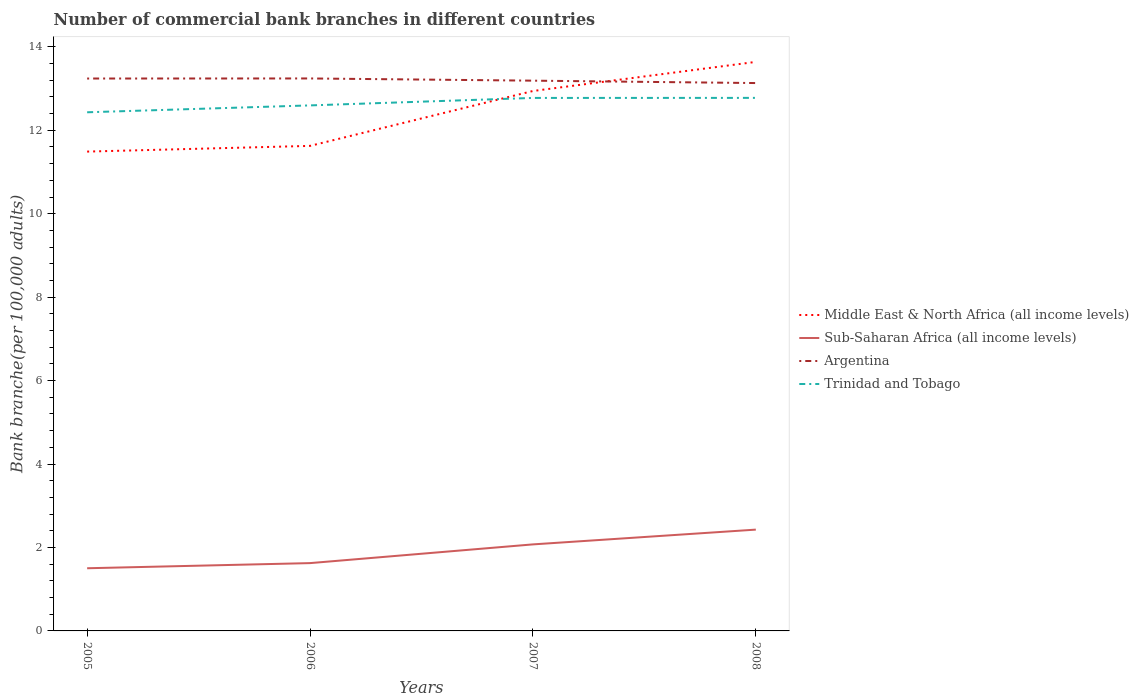Does the line corresponding to Trinidad and Tobago intersect with the line corresponding to Argentina?
Provide a short and direct response. No. Across all years, what is the maximum number of commercial bank branches in Trinidad and Tobago?
Your answer should be compact. 12.43. What is the total number of commercial bank branches in Argentina in the graph?
Give a very brief answer. 0.06. What is the difference between the highest and the second highest number of commercial bank branches in Middle East & North Africa (all income levels)?
Your answer should be compact. 2.15. How many lines are there?
Your response must be concise. 4. How many years are there in the graph?
Keep it short and to the point. 4. Are the values on the major ticks of Y-axis written in scientific E-notation?
Offer a very short reply. No. How are the legend labels stacked?
Your answer should be very brief. Vertical. What is the title of the graph?
Your answer should be compact. Number of commercial bank branches in different countries. What is the label or title of the X-axis?
Give a very brief answer. Years. What is the label or title of the Y-axis?
Make the answer very short. Bank branche(per 100,0 adults). What is the Bank branche(per 100,000 adults) in Middle East & North Africa (all income levels) in 2005?
Ensure brevity in your answer.  11.49. What is the Bank branche(per 100,000 adults) of Sub-Saharan Africa (all income levels) in 2005?
Your response must be concise. 1.5. What is the Bank branche(per 100,000 adults) of Argentina in 2005?
Give a very brief answer. 13.24. What is the Bank branche(per 100,000 adults) of Trinidad and Tobago in 2005?
Make the answer very short. 12.43. What is the Bank branche(per 100,000 adults) of Middle East & North Africa (all income levels) in 2006?
Your answer should be very brief. 11.63. What is the Bank branche(per 100,000 adults) of Sub-Saharan Africa (all income levels) in 2006?
Ensure brevity in your answer.  1.63. What is the Bank branche(per 100,000 adults) in Argentina in 2006?
Provide a short and direct response. 13.24. What is the Bank branche(per 100,000 adults) in Trinidad and Tobago in 2006?
Provide a short and direct response. 12.6. What is the Bank branche(per 100,000 adults) of Middle East & North Africa (all income levels) in 2007?
Your response must be concise. 12.94. What is the Bank branche(per 100,000 adults) in Sub-Saharan Africa (all income levels) in 2007?
Keep it short and to the point. 2.07. What is the Bank branche(per 100,000 adults) in Argentina in 2007?
Provide a short and direct response. 13.19. What is the Bank branche(per 100,000 adults) of Trinidad and Tobago in 2007?
Your answer should be compact. 12.77. What is the Bank branche(per 100,000 adults) in Middle East & North Africa (all income levels) in 2008?
Provide a succinct answer. 13.64. What is the Bank branche(per 100,000 adults) of Sub-Saharan Africa (all income levels) in 2008?
Ensure brevity in your answer.  2.43. What is the Bank branche(per 100,000 adults) of Argentina in 2008?
Give a very brief answer. 13.13. What is the Bank branche(per 100,000 adults) in Trinidad and Tobago in 2008?
Make the answer very short. 12.78. Across all years, what is the maximum Bank branche(per 100,000 adults) in Middle East & North Africa (all income levels)?
Provide a succinct answer. 13.64. Across all years, what is the maximum Bank branche(per 100,000 adults) of Sub-Saharan Africa (all income levels)?
Offer a terse response. 2.43. Across all years, what is the maximum Bank branche(per 100,000 adults) of Argentina?
Your answer should be very brief. 13.24. Across all years, what is the maximum Bank branche(per 100,000 adults) of Trinidad and Tobago?
Offer a terse response. 12.78. Across all years, what is the minimum Bank branche(per 100,000 adults) in Middle East & North Africa (all income levels)?
Provide a short and direct response. 11.49. Across all years, what is the minimum Bank branche(per 100,000 adults) of Sub-Saharan Africa (all income levels)?
Your response must be concise. 1.5. Across all years, what is the minimum Bank branche(per 100,000 adults) of Argentina?
Offer a very short reply. 13.13. Across all years, what is the minimum Bank branche(per 100,000 adults) of Trinidad and Tobago?
Offer a very short reply. 12.43. What is the total Bank branche(per 100,000 adults) in Middle East & North Africa (all income levels) in the graph?
Give a very brief answer. 49.69. What is the total Bank branche(per 100,000 adults) in Sub-Saharan Africa (all income levels) in the graph?
Provide a short and direct response. 7.63. What is the total Bank branche(per 100,000 adults) in Argentina in the graph?
Provide a succinct answer. 52.8. What is the total Bank branche(per 100,000 adults) of Trinidad and Tobago in the graph?
Provide a succinct answer. 50.58. What is the difference between the Bank branche(per 100,000 adults) in Middle East & North Africa (all income levels) in 2005 and that in 2006?
Your answer should be compact. -0.14. What is the difference between the Bank branche(per 100,000 adults) in Sub-Saharan Africa (all income levels) in 2005 and that in 2006?
Your answer should be very brief. -0.12. What is the difference between the Bank branche(per 100,000 adults) of Argentina in 2005 and that in 2006?
Provide a short and direct response. -0. What is the difference between the Bank branche(per 100,000 adults) in Trinidad and Tobago in 2005 and that in 2006?
Offer a very short reply. -0.16. What is the difference between the Bank branche(per 100,000 adults) of Middle East & North Africa (all income levels) in 2005 and that in 2007?
Your response must be concise. -1.45. What is the difference between the Bank branche(per 100,000 adults) of Sub-Saharan Africa (all income levels) in 2005 and that in 2007?
Give a very brief answer. -0.57. What is the difference between the Bank branche(per 100,000 adults) of Argentina in 2005 and that in 2007?
Your answer should be compact. 0.05. What is the difference between the Bank branche(per 100,000 adults) in Trinidad and Tobago in 2005 and that in 2007?
Your response must be concise. -0.34. What is the difference between the Bank branche(per 100,000 adults) in Middle East & North Africa (all income levels) in 2005 and that in 2008?
Your answer should be compact. -2.15. What is the difference between the Bank branche(per 100,000 adults) in Sub-Saharan Africa (all income levels) in 2005 and that in 2008?
Ensure brevity in your answer.  -0.93. What is the difference between the Bank branche(per 100,000 adults) of Argentina in 2005 and that in 2008?
Give a very brief answer. 0.11. What is the difference between the Bank branche(per 100,000 adults) in Trinidad and Tobago in 2005 and that in 2008?
Provide a succinct answer. -0.35. What is the difference between the Bank branche(per 100,000 adults) in Middle East & North Africa (all income levels) in 2006 and that in 2007?
Make the answer very short. -1.32. What is the difference between the Bank branche(per 100,000 adults) in Sub-Saharan Africa (all income levels) in 2006 and that in 2007?
Your response must be concise. -0.45. What is the difference between the Bank branche(per 100,000 adults) in Argentina in 2006 and that in 2007?
Give a very brief answer. 0.05. What is the difference between the Bank branche(per 100,000 adults) of Trinidad and Tobago in 2006 and that in 2007?
Your answer should be very brief. -0.18. What is the difference between the Bank branche(per 100,000 adults) in Middle East & North Africa (all income levels) in 2006 and that in 2008?
Make the answer very short. -2.01. What is the difference between the Bank branche(per 100,000 adults) of Sub-Saharan Africa (all income levels) in 2006 and that in 2008?
Your answer should be very brief. -0.8. What is the difference between the Bank branche(per 100,000 adults) of Argentina in 2006 and that in 2008?
Ensure brevity in your answer.  0.11. What is the difference between the Bank branche(per 100,000 adults) in Trinidad and Tobago in 2006 and that in 2008?
Offer a terse response. -0.18. What is the difference between the Bank branche(per 100,000 adults) in Middle East & North Africa (all income levels) in 2007 and that in 2008?
Make the answer very short. -0.7. What is the difference between the Bank branche(per 100,000 adults) in Sub-Saharan Africa (all income levels) in 2007 and that in 2008?
Make the answer very short. -0.35. What is the difference between the Bank branche(per 100,000 adults) in Argentina in 2007 and that in 2008?
Keep it short and to the point. 0.06. What is the difference between the Bank branche(per 100,000 adults) in Trinidad and Tobago in 2007 and that in 2008?
Provide a succinct answer. -0. What is the difference between the Bank branche(per 100,000 adults) of Middle East & North Africa (all income levels) in 2005 and the Bank branche(per 100,000 adults) of Sub-Saharan Africa (all income levels) in 2006?
Your answer should be compact. 9.86. What is the difference between the Bank branche(per 100,000 adults) of Middle East & North Africa (all income levels) in 2005 and the Bank branche(per 100,000 adults) of Argentina in 2006?
Offer a very short reply. -1.75. What is the difference between the Bank branche(per 100,000 adults) of Middle East & North Africa (all income levels) in 2005 and the Bank branche(per 100,000 adults) of Trinidad and Tobago in 2006?
Make the answer very short. -1.11. What is the difference between the Bank branche(per 100,000 adults) of Sub-Saharan Africa (all income levels) in 2005 and the Bank branche(per 100,000 adults) of Argentina in 2006?
Offer a terse response. -11.74. What is the difference between the Bank branche(per 100,000 adults) of Sub-Saharan Africa (all income levels) in 2005 and the Bank branche(per 100,000 adults) of Trinidad and Tobago in 2006?
Your answer should be compact. -11.09. What is the difference between the Bank branche(per 100,000 adults) of Argentina in 2005 and the Bank branche(per 100,000 adults) of Trinidad and Tobago in 2006?
Keep it short and to the point. 0.64. What is the difference between the Bank branche(per 100,000 adults) of Middle East & North Africa (all income levels) in 2005 and the Bank branche(per 100,000 adults) of Sub-Saharan Africa (all income levels) in 2007?
Offer a terse response. 9.41. What is the difference between the Bank branche(per 100,000 adults) of Middle East & North Africa (all income levels) in 2005 and the Bank branche(per 100,000 adults) of Trinidad and Tobago in 2007?
Your response must be concise. -1.29. What is the difference between the Bank branche(per 100,000 adults) in Sub-Saharan Africa (all income levels) in 2005 and the Bank branche(per 100,000 adults) in Argentina in 2007?
Keep it short and to the point. -11.69. What is the difference between the Bank branche(per 100,000 adults) of Sub-Saharan Africa (all income levels) in 2005 and the Bank branche(per 100,000 adults) of Trinidad and Tobago in 2007?
Your answer should be very brief. -11.27. What is the difference between the Bank branche(per 100,000 adults) of Argentina in 2005 and the Bank branche(per 100,000 adults) of Trinidad and Tobago in 2007?
Give a very brief answer. 0.47. What is the difference between the Bank branche(per 100,000 adults) in Middle East & North Africa (all income levels) in 2005 and the Bank branche(per 100,000 adults) in Sub-Saharan Africa (all income levels) in 2008?
Offer a terse response. 9.06. What is the difference between the Bank branche(per 100,000 adults) of Middle East & North Africa (all income levels) in 2005 and the Bank branche(per 100,000 adults) of Argentina in 2008?
Your answer should be very brief. -1.64. What is the difference between the Bank branche(per 100,000 adults) in Middle East & North Africa (all income levels) in 2005 and the Bank branche(per 100,000 adults) in Trinidad and Tobago in 2008?
Provide a short and direct response. -1.29. What is the difference between the Bank branche(per 100,000 adults) of Sub-Saharan Africa (all income levels) in 2005 and the Bank branche(per 100,000 adults) of Argentina in 2008?
Make the answer very short. -11.63. What is the difference between the Bank branche(per 100,000 adults) in Sub-Saharan Africa (all income levels) in 2005 and the Bank branche(per 100,000 adults) in Trinidad and Tobago in 2008?
Your response must be concise. -11.27. What is the difference between the Bank branche(per 100,000 adults) of Argentina in 2005 and the Bank branche(per 100,000 adults) of Trinidad and Tobago in 2008?
Your answer should be very brief. 0.46. What is the difference between the Bank branche(per 100,000 adults) of Middle East & North Africa (all income levels) in 2006 and the Bank branche(per 100,000 adults) of Sub-Saharan Africa (all income levels) in 2007?
Make the answer very short. 9.55. What is the difference between the Bank branche(per 100,000 adults) in Middle East & North Africa (all income levels) in 2006 and the Bank branche(per 100,000 adults) in Argentina in 2007?
Offer a very short reply. -1.56. What is the difference between the Bank branche(per 100,000 adults) in Middle East & North Africa (all income levels) in 2006 and the Bank branche(per 100,000 adults) in Trinidad and Tobago in 2007?
Provide a succinct answer. -1.15. What is the difference between the Bank branche(per 100,000 adults) in Sub-Saharan Africa (all income levels) in 2006 and the Bank branche(per 100,000 adults) in Argentina in 2007?
Your answer should be compact. -11.56. What is the difference between the Bank branche(per 100,000 adults) of Sub-Saharan Africa (all income levels) in 2006 and the Bank branche(per 100,000 adults) of Trinidad and Tobago in 2007?
Your answer should be compact. -11.15. What is the difference between the Bank branche(per 100,000 adults) of Argentina in 2006 and the Bank branche(per 100,000 adults) of Trinidad and Tobago in 2007?
Provide a short and direct response. 0.47. What is the difference between the Bank branche(per 100,000 adults) in Middle East & North Africa (all income levels) in 2006 and the Bank branche(per 100,000 adults) in Sub-Saharan Africa (all income levels) in 2008?
Ensure brevity in your answer.  9.2. What is the difference between the Bank branche(per 100,000 adults) in Middle East & North Africa (all income levels) in 2006 and the Bank branche(per 100,000 adults) in Argentina in 2008?
Make the answer very short. -1.51. What is the difference between the Bank branche(per 100,000 adults) of Middle East & North Africa (all income levels) in 2006 and the Bank branche(per 100,000 adults) of Trinidad and Tobago in 2008?
Your response must be concise. -1.15. What is the difference between the Bank branche(per 100,000 adults) in Sub-Saharan Africa (all income levels) in 2006 and the Bank branche(per 100,000 adults) in Argentina in 2008?
Provide a succinct answer. -11.51. What is the difference between the Bank branche(per 100,000 adults) in Sub-Saharan Africa (all income levels) in 2006 and the Bank branche(per 100,000 adults) in Trinidad and Tobago in 2008?
Offer a terse response. -11.15. What is the difference between the Bank branche(per 100,000 adults) of Argentina in 2006 and the Bank branche(per 100,000 adults) of Trinidad and Tobago in 2008?
Keep it short and to the point. 0.47. What is the difference between the Bank branche(per 100,000 adults) of Middle East & North Africa (all income levels) in 2007 and the Bank branche(per 100,000 adults) of Sub-Saharan Africa (all income levels) in 2008?
Offer a terse response. 10.51. What is the difference between the Bank branche(per 100,000 adults) of Middle East & North Africa (all income levels) in 2007 and the Bank branche(per 100,000 adults) of Argentina in 2008?
Offer a terse response. -0.19. What is the difference between the Bank branche(per 100,000 adults) in Middle East & North Africa (all income levels) in 2007 and the Bank branche(per 100,000 adults) in Trinidad and Tobago in 2008?
Ensure brevity in your answer.  0.17. What is the difference between the Bank branche(per 100,000 adults) in Sub-Saharan Africa (all income levels) in 2007 and the Bank branche(per 100,000 adults) in Argentina in 2008?
Offer a very short reply. -11.06. What is the difference between the Bank branche(per 100,000 adults) in Sub-Saharan Africa (all income levels) in 2007 and the Bank branche(per 100,000 adults) in Trinidad and Tobago in 2008?
Your answer should be compact. -10.7. What is the difference between the Bank branche(per 100,000 adults) of Argentina in 2007 and the Bank branche(per 100,000 adults) of Trinidad and Tobago in 2008?
Offer a terse response. 0.41. What is the average Bank branche(per 100,000 adults) in Middle East & North Africa (all income levels) per year?
Your answer should be compact. 12.42. What is the average Bank branche(per 100,000 adults) in Sub-Saharan Africa (all income levels) per year?
Your answer should be compact. 1.91. What is the average Bank branche(per 100,000 adults) in Argentina per year?
Your answer should be compact. 13.2. What is the average Bank branche(per 100,000 adults) in Trinidad and Tobago per year?
Provide a succinct answer. 12.64. In the year 2005, what is the difference between the Bank branche(per 100,000 adults) in Middle East & North Africa (all income levels) and Bank branche(per 100,000 adults) in Sub-Saharan Africa (all income levels)?
Make the answer very short. 9.99. In the year 2005, what is the difference between the Bank branche(per 100,000 adults) in Middle East & North Africa (all income levels) and Bank branche(per 100,000 adults) in Argentina?
Your response must be concise. -1.75. In the year 2005, what is the difference between the Bank branche(per 100,000 adults) of Middle East & North Africa (all income levels) and Bank branche(per 100,000 adults) of Trinidad and Tobago?
Make the answer very short. -0.94. In the year 2005, what is the difference between the Bank branche(per 100,000 adults) of Sub-Saharan Africa (all income levels) and Bank branche(per 100,000 adults) of Argentina?
Provide a short and direct response. -11.74. In the year 2005, what is the difference between the Bank branche(per 100,000 adults) in Sub-Saharan Africa (all income levels) and Bank branche(per 100,000 adults) in Trinidad and Tobago?
Make the answer very short. -10.93. In the year 2005, what is the difference between the Bank branche(per 100,000 adults) in Argentina and Bank branche(per 100,000 adults) in Trinidad and Tobago?
Give a very brief answer. 0.81. In the year 2006, what is the difference between the Bank branche(per 100,000 adults) of Middle East & North Africa (all income levels) and Bank branche(per 100,000 adults) of Sub-Saharan Africa (all income levels)?
Provide a succinct answer. 10. In the year 2006, what is the difference between the Bank branche(per 100,000 adults) in Middle East & North Africa (all income levels) and Bank branche(per 100,000 adults) in Argentina?
Provide a succinct answer. -1.62. In the year 2006, what is the difference between the Bank branche(per 100,000 adults) of Middle East & North Africa (all income levels) and Bank branche(per 100,000 adults) of Trinidad and Tobago?
Ensure brevity in your answer.  -0.97. In the year 2006, what is the difference between the Bank branche(per 100,000 adults) of Sub-Saharan Africa (all income levels) and Bank branche(per 100,000 adults) of Argentina?
Offer a terse response. -11.62. In the year 2006, what is the difference between the Bank branche(per 100,000 adults) in Sub-Saharan Africa (all income levels) and Bank branche(per 100,000 adults) in Trinidad and Tobago?
Ensure brevity in your answer.  -10.97. In the year 2006, what is the difference between the Bank branche(per 100,000 adults) of Argentina and Bank branche(per 100,000 adults) of Trinidad and Tobago?
Offer a very short reply. 0.65. In the year 2007, what is the difference between the Bank branche(per 100,000 adults) in Middle East & North Africa (all income levels) and Bank branche(per 100,000 adults) in Sub-Saharan Africa (all income levels)?
Your answer should be compact. 10.87. In the year 2007, what is the difference between the Bank branche(per 100,000 adults) in Middle East & North Africa (all income levels) and Bank branche(per 100,000 adults) in Argentina?
Offer a terse response. -0.25. In the year 2007, what is the difference between the Bank branche(per 100,000 adults) of Middle East & North Africa (all income levels) and Bank branche(per 100,000 adults) of Trinidad and Tobago?
Ensure brevity in your answer.  0.17. In the year 2007, what is the difference between the Bank branche(per 100,000 adults) in Sub-Saharan Africa (all income levels) and Bank branche(per 100,000 adults) in Argentina?
Your response must be concise. -11.11. In the year 2007, what is the difference between the Bank branche(per 100,000 adults) of Sub-Saharan Africa (all income levels) and Bank branche(per 100,000 adults) of Trinidad and Tobago?
Offer a very short reply. -10.7. In the year 2007, what is the difference between the Bank branche(per 100,000 adults) in Argentina and Bank branche(per 100,000 adults) in Trinidad and Tobago?
Your answer should be very brief. 0.41. In the year 2008, what is the difference between the Bank branche(per 100,000 adults) of Middle East & North Africa (all income levels) and Bank branche(per 100,000 adults) of Sub-Saharan Africa (all income levels)?
Offer a very short reply. 11.21. In the year 2008, what is the difference between the Bank branche(per 100,000 adults) of Middle East & North Africa (all income levels) and Bank branche(per 100,000 adults) of Argentina?
Keep it short and to the point. 0.51. In the year 2008, what is the difference between the Bank branche(per 100,000 adults) of Middle East & North Africa (all income levels) and Bank branche(per 100,000 adults) of Trinidad and Tobago?
Provide a succinct answer. 0.86. In the year 2008, what is the difference between the Bank branche(per 100,000 adults) of Sub-Saharan Africa (all income levels) and Bank branche(per 100,000 adults) of Argentina?
Give a very brief answer. -10.7. In the year 2008, what is the difference between the Bank branche(per 100,000 adults) in Sub-Saharan Africa (all income levels) and Bank branche(per 100,000 adults) in Trinidad and Tobago?
Your answer should be very brief. -10.35. In the year 2008, what is the difference between the Bank branche(per 100,000 adults) in Argentina and Bank branche(per 100,000 adults) in Trinidad and Tobago?
Your response must be concise. 0.36. What is the ratio of the Bank branche(per 100,000 adults) in Sub-Saharan Africa (all income levels) in 2005 to that in 2006?
Your response must be concise. 0.92. What is the ratio of the Bank branche(per 100,000 adults) of Trinidad and Tobago in 2005 to that in 2006?
Your answer should be compact. 0.99. What is the ratio of the Bank branche(per 100,000 adults) of Middle East & North Africa (all income levels) in 2005 to that in 2007?
Give a very brief answer. 0.89. What is the ratio of the Bank branche(per 100,000 adults) in Sub-Saharan Africa (all income levels) in 2005 to that in 2007?
Provide a succinct answer. 0.72. What is the ratio of the Bank branche(per 100,000 adults) of Trinidad and Tobago in 2005 to that in 2007?
Provide a short and direct response. 0.97. What is the ratio of the Bank branche(per 100,000 adults) in Middle East & North Africa (all income levels) in 2005 to that in 2008?
Offer a terse response. 0.84. What is the ratio of the Bank branche(per 100,000 adults) in Sub-Saharan Africa (all income levels) in 2005 to that in 2008?
Offer a very short reply. 0.62. What is the ratio of the Bank branche(per 100,000 adults) in Argentina in 2005 to that in 2008?
Make the answer very short. 1.01. What is the ratio of the Bank branche(per 100,000 adults) in Trinidad and Tobago in 2005 to that in 2008?
Provide a succinct answer. 0.97. What is the ratio of the Bank branche(per 100,000 adults) in Middle East & North Africa (all income levels) in 2006 to that in 2007?
Offer a terse response. 0.9. What is the ratio of the Bank branche(per 100,000 adults) of Sub-Saharan Africa (all income levels) in 2006 to that in 2007?
Your response must be concise. 0.78. What is the ratio of the Bank branche(per 100,000 adults) of Argentina in 2006 to that in 2007?
Keep it short and to the point. 1. What is the ratio of the Bank branche(per 100,000 adults) in Trinidad and Tobago in 2006 to that in 2007?
Your answer should be compact. 0.99. What is the ratio of the Bank branche(per 100,000 adults) in Middle East & North Africa (all income levels) in 2006 to that in 2008?
Your response must be concise. 0.85. What is the ratio of the Bank branche(per 100,000 adults) in Sub-Saharan Africa (all income levels) in 2006 to that in 2008?
Give a very brief answer. 0.67. What is the ratio of the Bank branche(per 100,000 adults) in Argentina in 2006 to that in 2008?
Make the answer very short. 1.01. What is the ratio of the Bank branche(per 100,000 adults) of Trinidad and Tobago in 2006 to that in 2008?
Provide a short and direct response. 0.99. What is the ratio of the Bank branche(per 100,000 adults) of Middle East & North Africa (all income levels) in 2007 to that in 2008?
Your answer should be very brief. 0.95. What is the ratio of the Bank branche(per 100,000 adults) in Sub-Saharan Africa (all income levels) in 2007 to that in 2008?
Offer a terse response. 0.85. What is the ratio of the Bank branche(per 100,000 adults) in Argentina in 2007 to that in 2008?
Your response must be concise. 1. What is the ratio of the Bank branche(per 100,000 adults) in Trinidad and Tobago in 2007 to that in 2008?
Your answer should be compact. 1. What is the difference between the highest and the second highest Bank branche(per 100,000 adults) of Middle East & North Africa (all income levels)?
Your answer should be very brief. 0.7. What is the difference between the highest and the second highest Bank branche(per 100,000 adults) of Sub-Saharan Africa (all income levels)?
Your response must be concise. 0.35. What is the difference between the highest and the second highest Bank branche(per 100,000 adults) in Argentina?
Keep it short and to the point. 0. What is the difference between the highest and the second highest Bank branche(per 100,000 adults) of Trinidad and Tobago?
Offer a terse response. 0. What is the difference between the highest and the lowest Bank branche(per 100,000 adults) of Middle East & North Africa (all income levels)?
Your answer should be very brief. 2.15. What is the difference between the highest and the lowest Bank branche(per 100,000 adults) of Sub-Saharan Africa (all income levels)?
Your answer should be compact. 0.93. What is the difference between the highest and the lowest Bank branche(per 100,000 adults) in Argentina?
Provide a short and direct response. 0.11. What is the difference between the highest and the lowest Bank branche(per 100,000 adults) of Trinidad and Tobago?
Offer a very short reply. 0.35. 